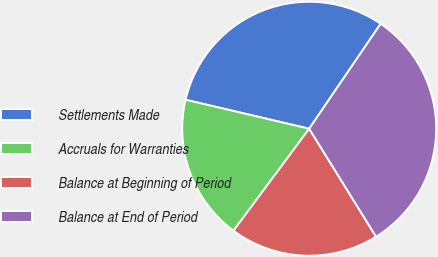<chart> <loc_0><loc_0><loc_500><loc_500><pie_chart><fcel>Settlements Made<fcel>Accruals for Warranties<fcel>Balance at Beginning of Period<fcel>Balance at End of Period<nl><fcel>30.85%<fcel>18.5%<fcel>18.99%<fcel>31.66%<nl></chart> 